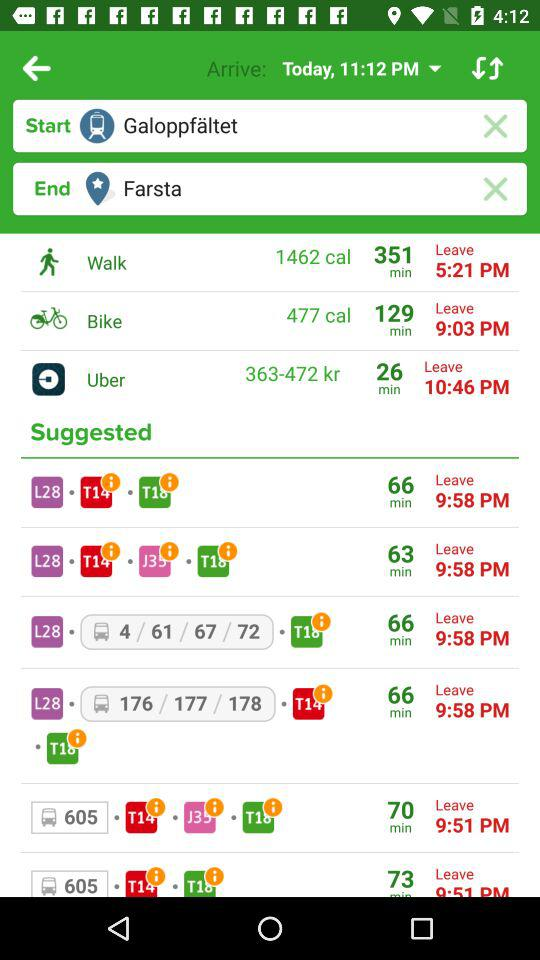What is the bike's duration? The bike's duration is 129 minutes. 